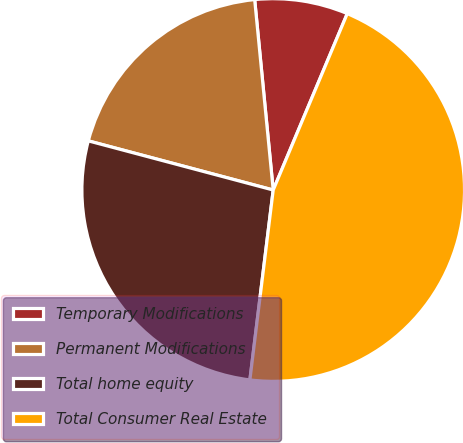<chart> <loc_0><loc_0><loc_500><loc_500><pie_chart><fcel>Temporary Modifications<fcel>Permanent Modifications<fcel>Total home equity<fcel>Total Consumer Real Estate<nl><fcel>7.87%<fcel>19.32%<fcel>27.19%<fcel>45.62%<nl></chart> 